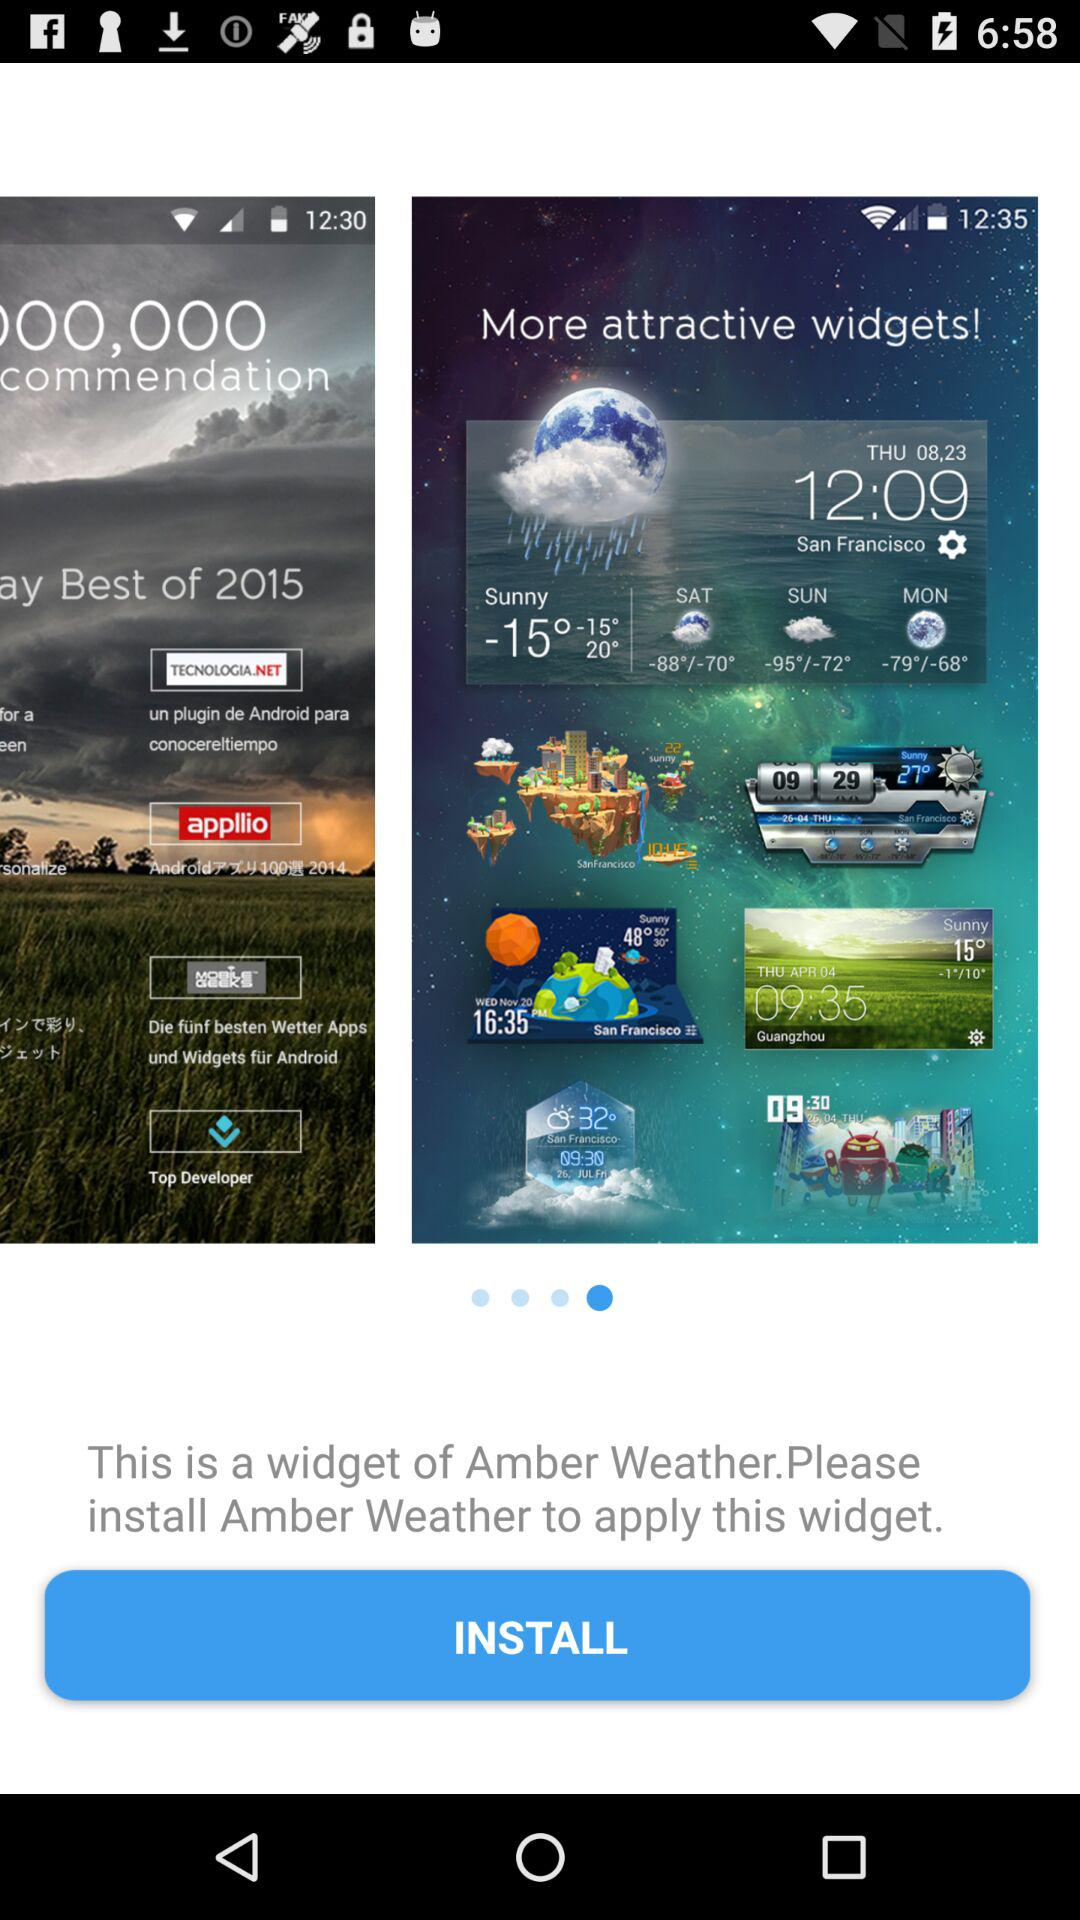Which is date given?
When the provided information is insufficient, respond with <no answer>. <no answer> 